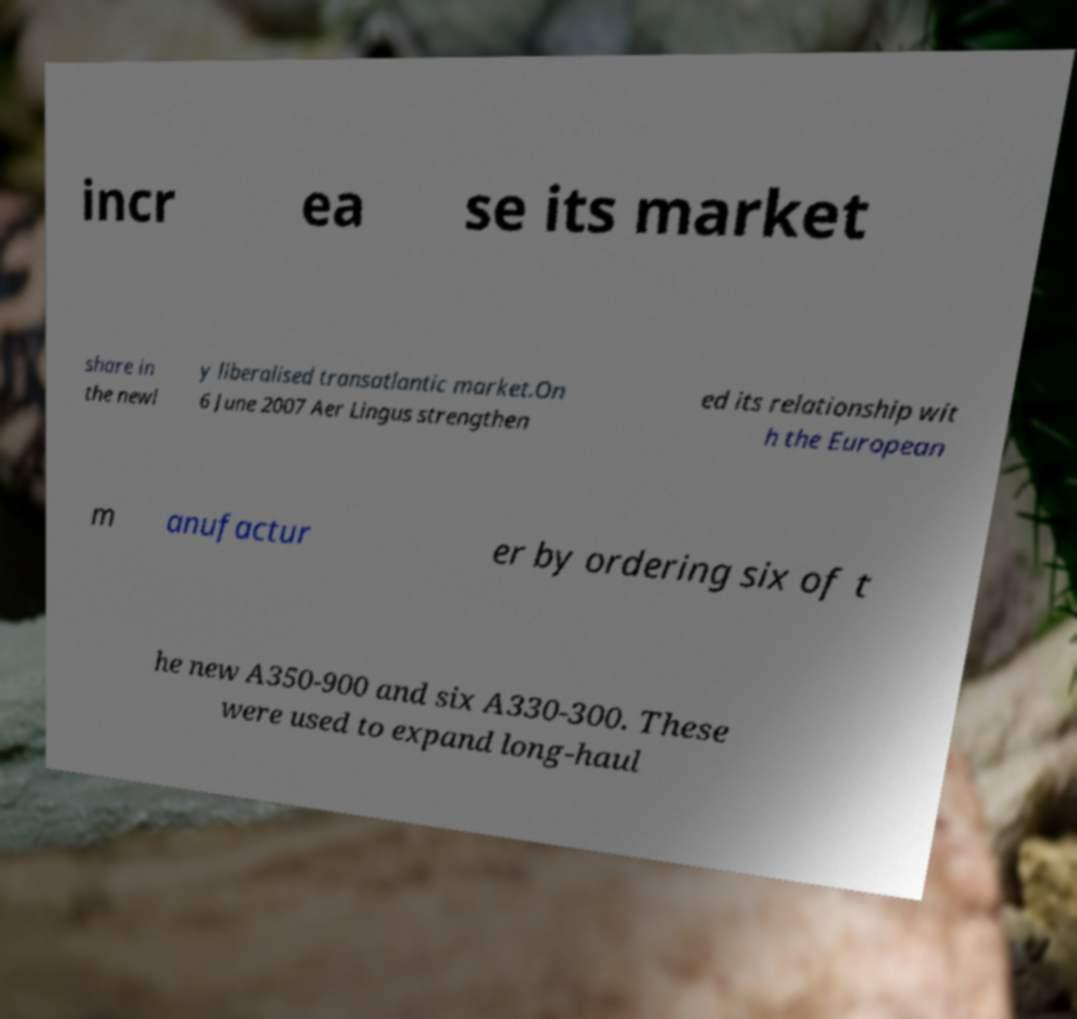I need the written content from this picture converted into text. Can you do that? incr ea se its market share in the newl y liberalised transatlantic market.On 6 June 2007 Aer Lingus strengthen ed its relationship wit h the European m anufactur er by ordering six of t he new A350-900 and six A330-300. These were used to expand long-haul 